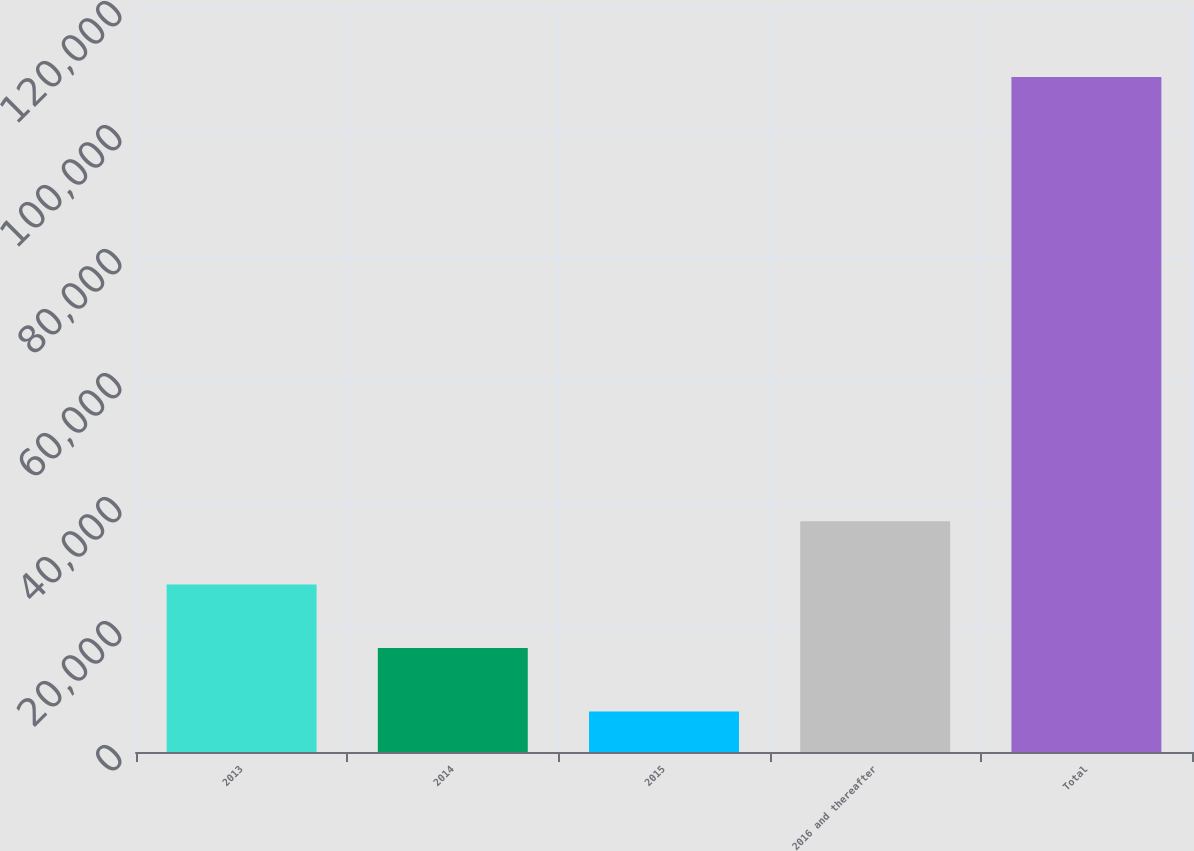Convert chart. <chart><loc_0><loc_0><loc_500><loc_500><bar_chart><fcel>2013<fcel>2014<fcel>2015<fcel>2016 and thereafter<fcel>Total<nl><fcel>27001.4<fcel>16767.7<fcel>6534<fcel>37235.1<fcel>108871<nl></chart> 